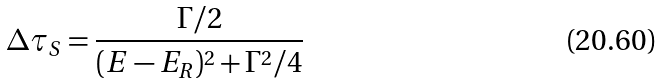Convert formula to latex. <formula><loc_0><loc_0><loc_500><loc_500>\Delta \tau _ { S } = \frac { \Gamma / 2 } { ( E - E _ { R } ) ^ { 2 } + \Gamma ^ { 2 } / 4 }</formula> 